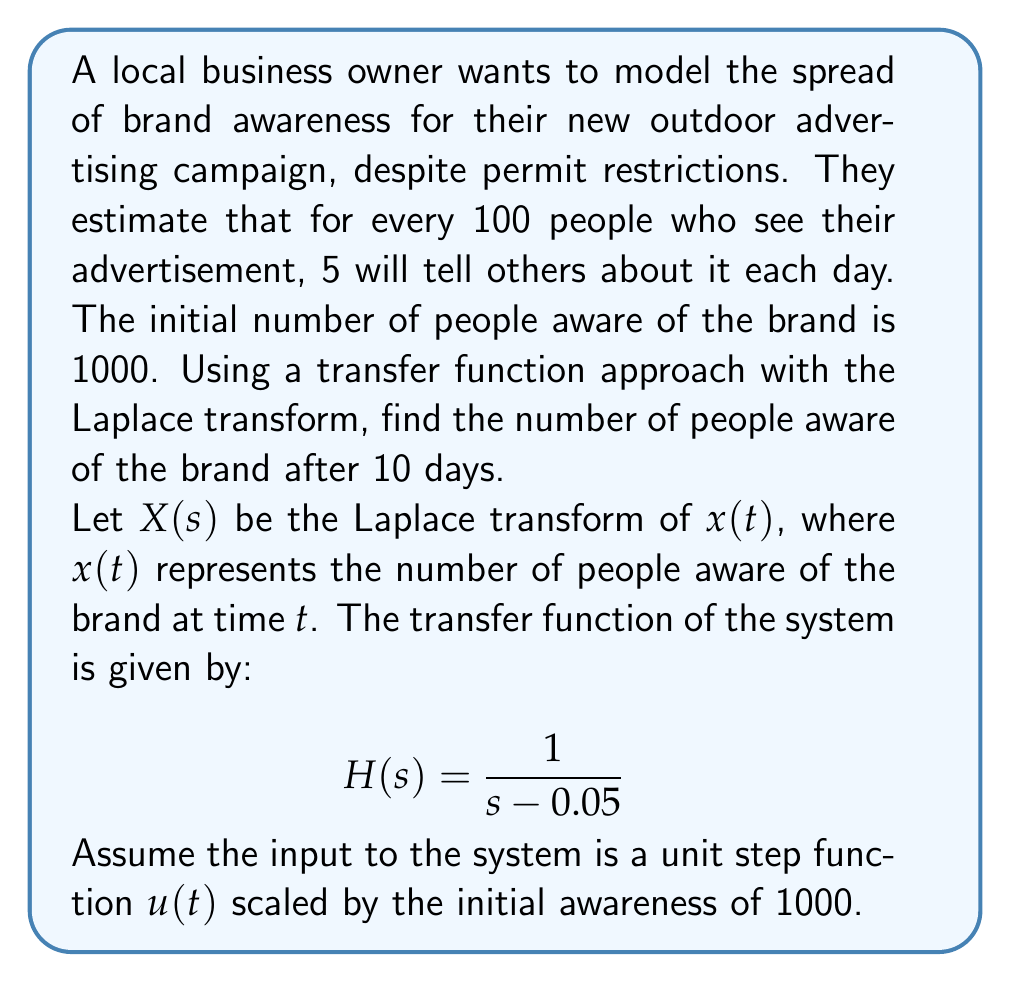Can you solve this math problem? Let's approach this step-by-step:

1) The input to the system is $1000u(t)$, where $u(t)$ is the unit step function. The Laplace transform of this input is:

   $$U(s) = \frac{1000}{s}$$

2) The output in the s-domain is the product of the input and the transfer function:

   $$X(s) = U(s) \cdot H(s) = \frac{1000}{s} \cdot \frac{1}{s - 0.05}$$

3) Simplify:

   $$X(s) = \frac{1000}{s(s - 0.05)}$$

4) Use partial fraction decomposition:

   $$X(s) = \frac{A}{s} + \frac{B}{s - 0.05}$$

   where $A = 1000$ and $B = -1000$

5) Therefore:

   $$X(s) = \frac{1000}{s} - \frac{1000}{s - 0.05}$$

6) Take the inverse Laplace transform:

   $$x(t) = 1000 - 1000e^{0.05t}$$

7) To find the number of people aware after 10 days, substitute $t = 10$:

   $$x(10) = 1000 - 1000e^{0.5} = 1000(1 - e^{0.5})$$

8) Calculate the final value:

   $$x(10) = 1000(1 - e^{0.5}) \approx 393.47$$
Answer: 1393 people (rounded to nearest whole number) 